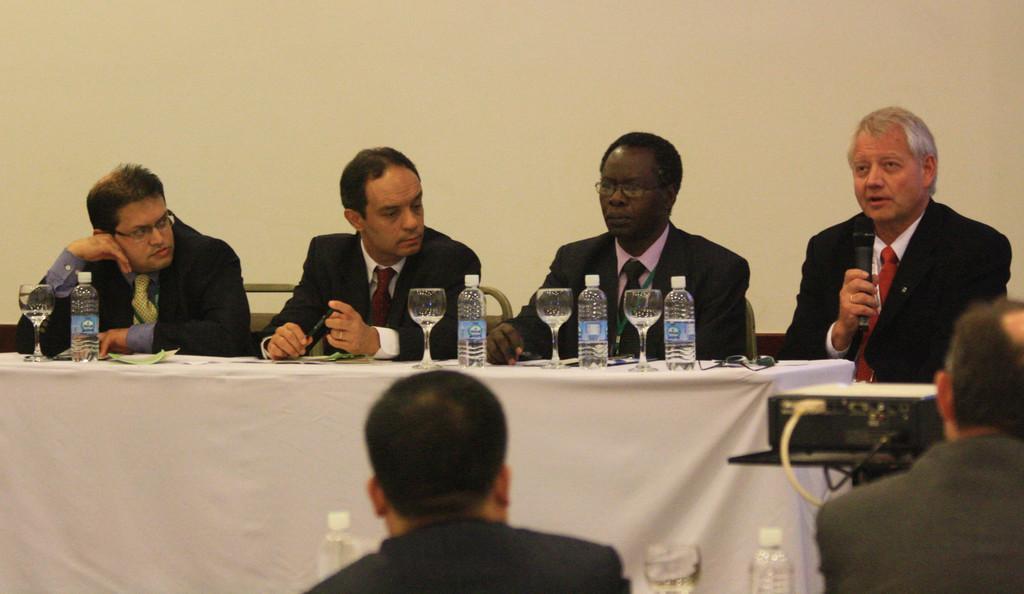In one or two sentences, can you explain what this image depicts? In this image I can see four persons wearing blazers and ties are sitting in front of a table and on the table I can see few bottles, few glasses and few other objects. I can see a electronic device, a microphone in person's hand, two persons sitting, few water bottles and the cream colored wall in the background. 